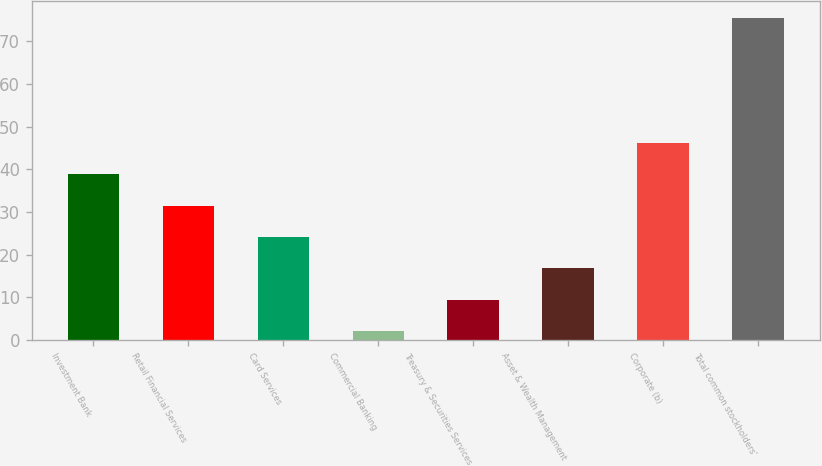Convert chart. <chart><loc_0><loc_0><loc_500><loc_500><bar_chart><fcel>Investment Bank<fcel>Retail Financial Services<fcel>Card Services<fcel>Commercial Banking<fcel>Treasury & Securities Services<fcel>Asset & Wealth Management<fcel>Corporate (b)<fcel>Total common stockholders'<nl><fcel>38.85<fcel>31.5<fcel>24.15<fcel>2.1<fcel>9.45<fcel>16.8<fcel>46.2<fcel>75.6<nl></chart> 